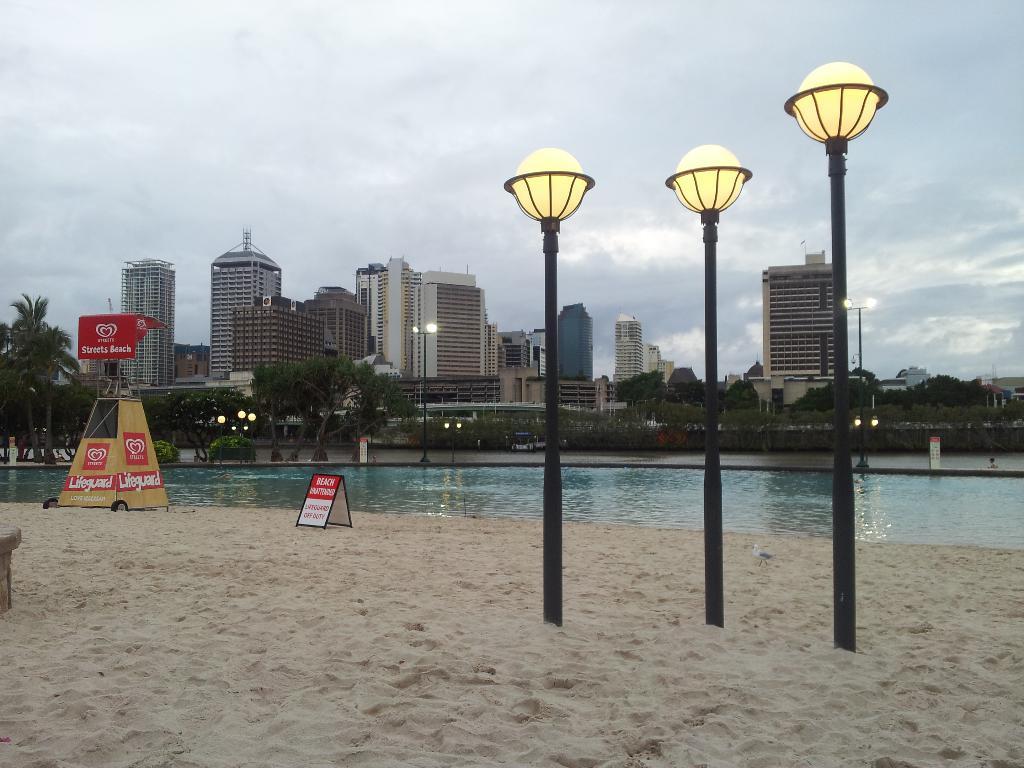In one or two sentences, can you explain what this image depicts? In this picture we can see poles, sand, boards, water, trees, buildings and in the background we can see the sky with clouds. 